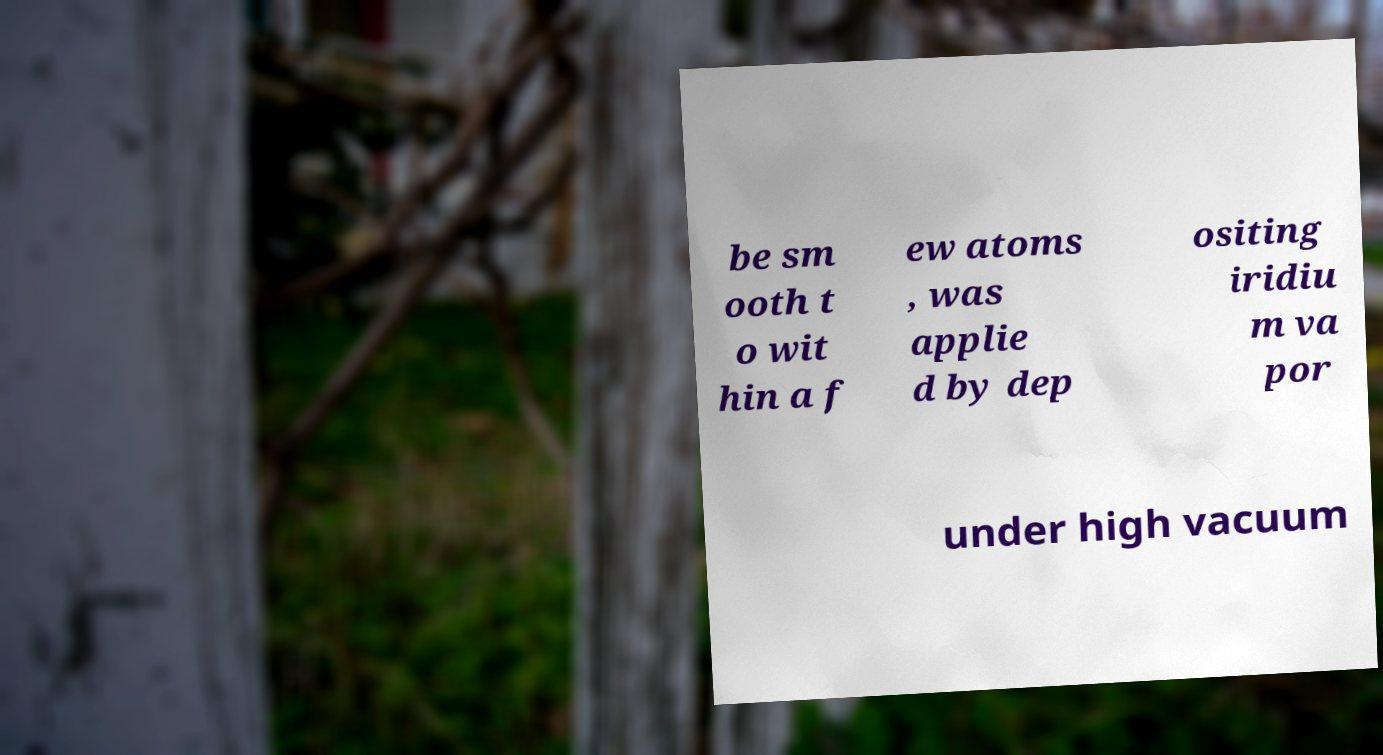What messages or text are displayed in this image? I need them in a readable, typed format. be sm ooth t o wit hin a f ew atoms , was applie d by dep ositing iridiu m va por under high vacuum 